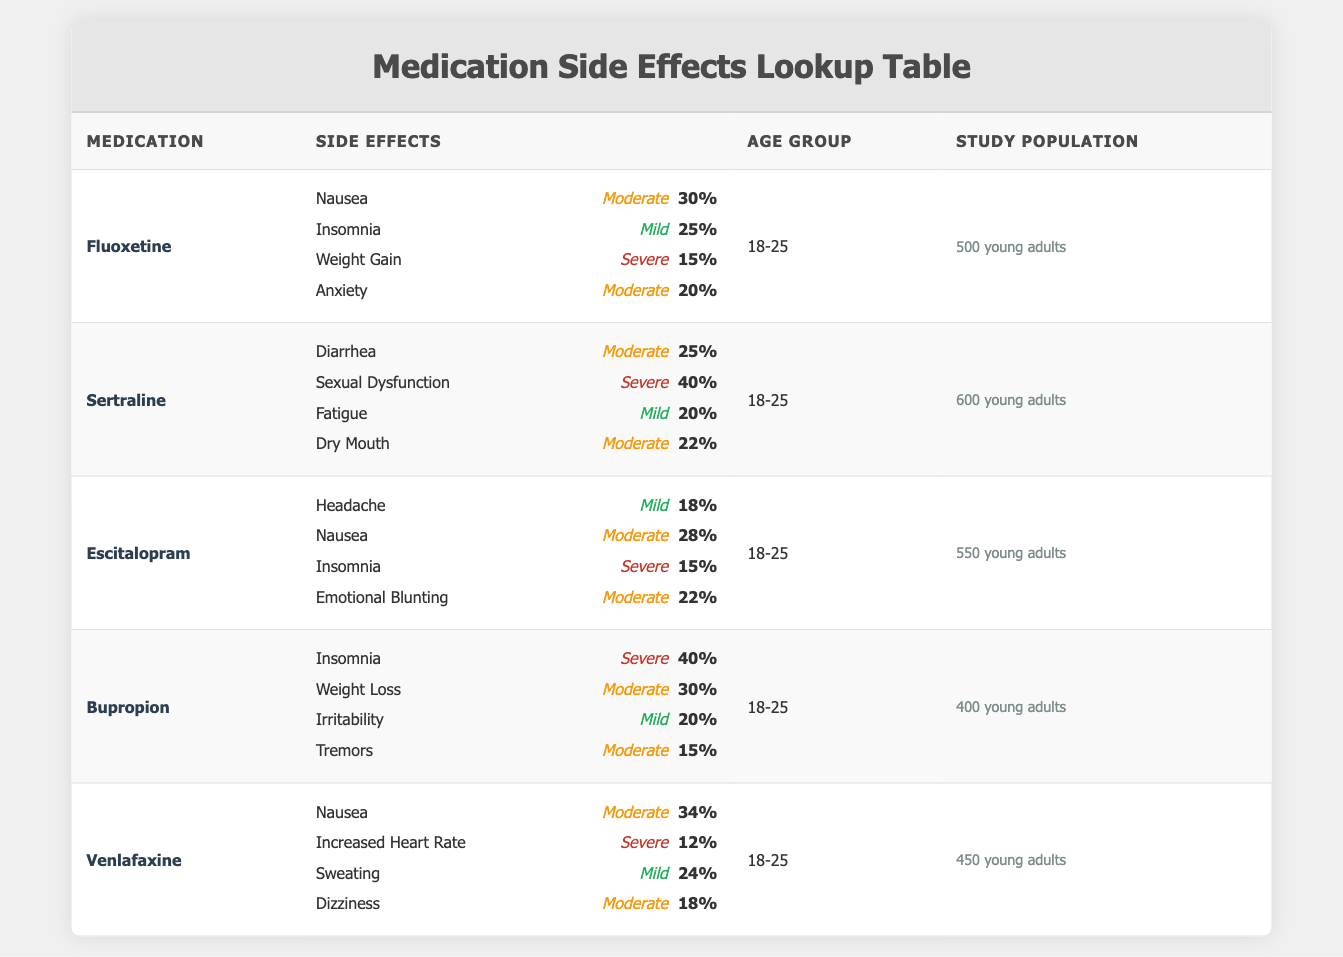What percentage of young adults reported experiencing insomnia as a side effect of Bupropion? The table shows that 40% of the participants reported insomnia as a side effect of Bupropion.
Answer: 40% Which medication has the highest reported percentage for sexual dysfunction? In the table, Sertraline is listed with 40% of participants reporting sexual dysfunction, which is the highest percentage among the listed side effects.
Answer: Sertraline What is the average percentage of young adults reporting nausea across all medications? The reported percentages for nausea are: Fluoxetine (30%), Escitalopram (28%), Venlafaxine (34%). The average is calculated as (30 + 28 + 34) / 3 = 30.67.
Answer: 30.67% Is the side effect of emotional blunting more often reported than dry mouth? Emotional blunting was reported by 22% of participants taking Escitalopram, while dry mouth was reported by 22% of participants taking Sertraline. Since these percentages are equal, the answer is no.
Answer: No What is the total number of young adults involved in the study for Fluoxetine and Bupropion? The study populations for Fluoxetine is 500 and for Bupropion is 400. Adding these gives a total of 500 + 400 = 900 young adults.
Answer: 900 What medication shows the least percentage of mild side effects reported? The table shows that Bupropion has only one mild side effect, irritability at 20%, whereas other medications report varying mild side effects. Therefore, Bupropion has the lowest percentage of mild side effects among the ones listed.
Answer: Bupropion Which medication shows the highest severity of nausea among young adults, and what is its percentage? Among the medications listed, Venlafaxine reports nausea at a moderate severity level for 34% of participants. This is the highest percentage for nausea compared to others.
Answer: Venlafaxine, 34% If you only consider severe side effects, which medication has the most reported severe side effects overall? The medications with severe side effects are Sertraline (40% for sexual dysfunction), Bupropion (40% for insomnia), and Venlafaxine (12% for increased heart rate). Both Sertraline and Bupropion are tied, with the highest severe side effect percentage of 40%.
Answer: Sertraline and Bupropion What percentage of young adults reported anxiety as a side effect of Fluoxetine? The table indicates that 20% of young adults reported experiencing anxiety as a side effect of Fluoxetine.
Answer: 20% 